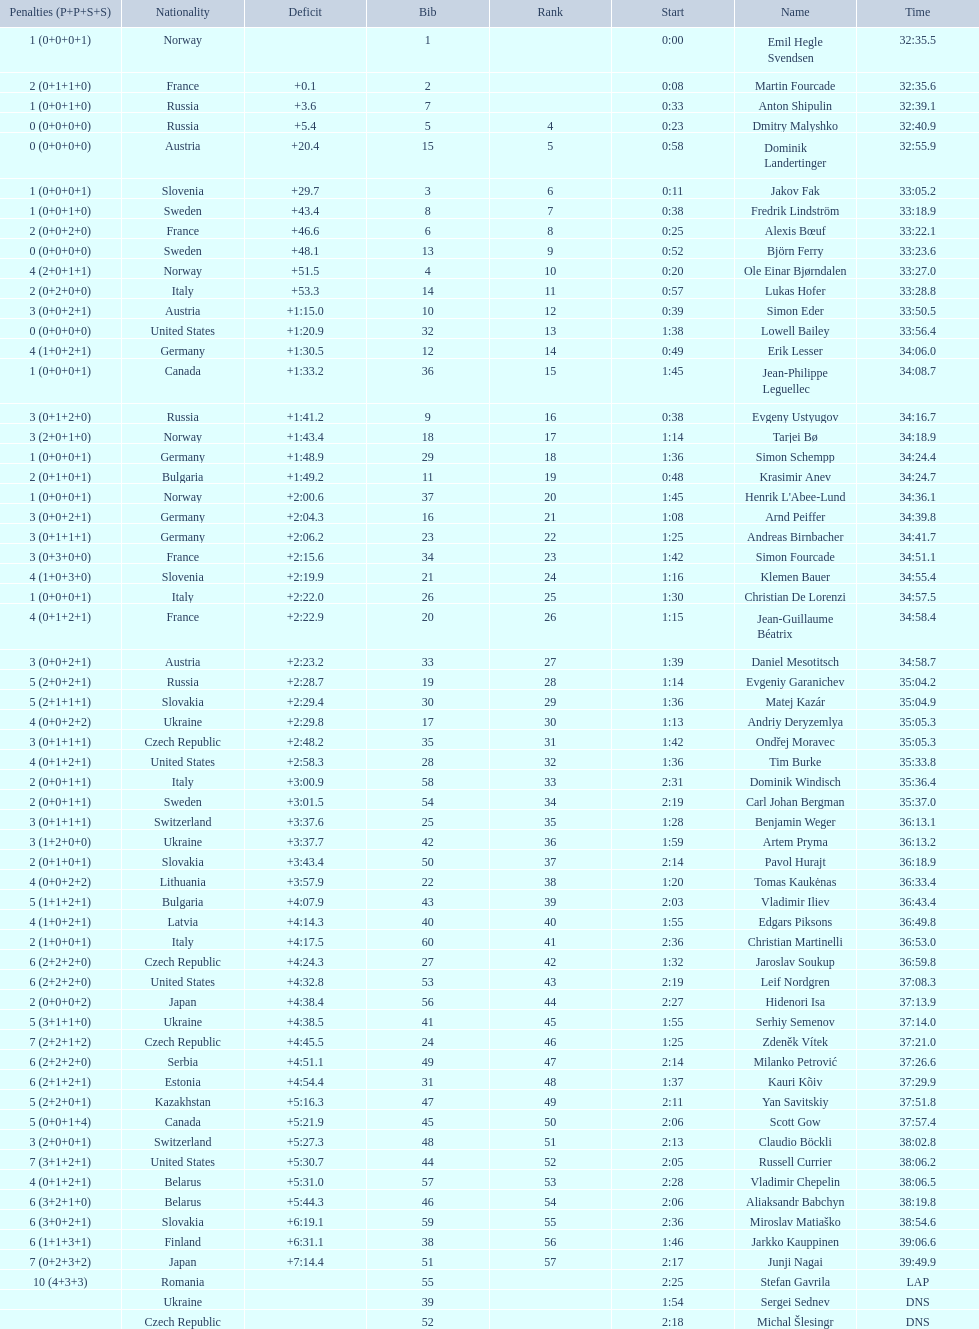What were the total number of "ties" (people who finished with the exact same time?) 2. 